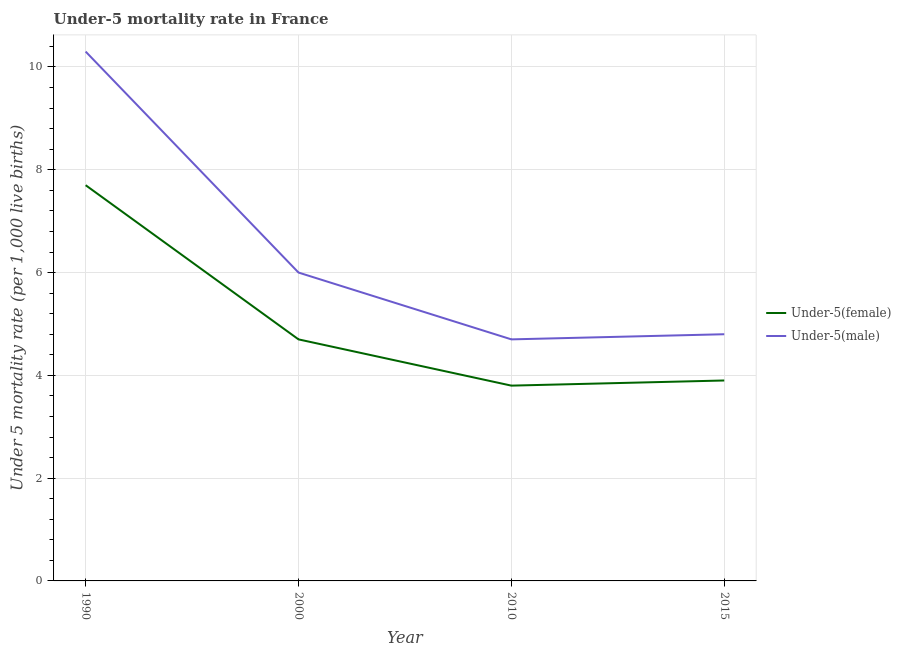How many different coloured lines are there?
Provide a short and direct response. 2. Does the line corresponding to under-5 male mortality rate intersect with the line corresponding to under-5 female mortality rate?
Your answer should be compact. No. In which year was the under-5 male mortality rate maximum?
Your answer should be very brief. 1990. What is the total under-5 female mortality rate in the graph?
Your answer should be very brief. 20.1. What is the difference between the under-5 male mortality rate in 1990 and that in 2000?
Your answer should be very brief. 4.3. What is the difference between the under-5 male mortality rate in 2015 and the under-5 female mortality rate in 1990?
Ensure brevity in your answer.  -2.9. What is the average under-5 male mortality rate per year?
Offer a very short reply. 6.45. In the year 2015, what is the difference between the under-5 female mortality rate and under-5 male mortality rate?
Give a very brief answer. -0.9. In how many years, is the under-5 female mortality rate greater than 8.4?
Offer a terse response. 0. What is the ratio of the under-5 female mortality rate in 2010 to that in 2015?
Provide a short and direct response. 0.97. Is the difference between the under-5 male mortality rate in 1990 and 2000 greater than the difference between the under-5 female mortality rate in 1990 and 2000?
Ensure brevity in your answer.  Yes. What is the difference between the highest and the second highest under-5 male mortality rate?
Provide a succinct answer. 4.3. What is the difference between the highest and the lowest under-5 male mortality rate?
Give a very brief answer. 5.6. Is the sum of the under-5 female mortality rate in 1990 and 2000 greater than the maximum under-5 male mortality rate across all years?
Give a very brief answer. Yes. Does the under-5 female mortality rate monotonically increase over the years?
Provide a succinct answer. No. Is the under-5 male mortality rate strictly greater than the under-5 female mortality rate over the years?
Provide a short and direct response. Yes. How many lines are there?
Ensure brevity in your answer.  2. What is the difference between two consecutive major ticks on the Y-axis?
Ensure brevity in your answer.  2. Are the values on the major ticks of Y-axis written in scientific E-notation?
Your answer should be compact. No. Where does the legend appear in the graph?
Your answer should be very brief. Center right. How many legend labels are there?
Your answer should be very brief. 2. What is the title of the graph?
Provide a succinct answer. Under-5 mortality rate in France. Does "Depositors" appear as one of the legend labels in the graph?
Make the answer very short. No. What is the label or title of the X-axis?
Your answer should be compact. Year. What is the label or title of the Y-axis?
Your answer should be compact. Under 5 mortality rate (per 1,0 live births). What is the Under 5 mortality rate (per 1,000 live births) of Under-5(female) in 1990?
Make the answer very short. 7.7. What is the Under 5 mortality rate (per 1,000 live births) in Under-5(male) in 1990?
Make the answer very short. 10.3. What is the Under 5 mortality rate (per 1,000 live births) in Under-5(female) in 2000?
Your answer should be compact. 4.7. What is the Under 5 mortality rate (per 1,000 live births) in Under-5(male) in 2000?
Offer a very short reply. 6. What is the Under 5 mortality rate (per 1,000 live births) in Under-5(female) in 2010?
Make the answer very short. 3.8. What is the Under 5 mortality rate (per 1,000 live births) of Under-5(male) in 2010?
Your response must be concise. 4.7. What is the Under 5 mortality rate (per 1,000 live births) in Under-5(male) in 2015?
Give a very brief answer. 4.8. Across all years, what is the minimum Under 5 mortality rate (per 1,000 live births) in Under-5(female)?
Keep it short and to the point. 3.8. Across all years, what is the minimum Under 5 mortality rate (per 1,000 live births) in Under-5(male)?
Offer a terse response. 4.7. What is the total Under 5 mortality rate (per 1,000 live births) in Under-5(female) in the graph?
Provide a succinct answer. 20.1. What is the total Under 5 mortality rate (per 1,000 live births) of Under-5(male) in the graph?
Offer a terse response. 25.8. What is the difference between the Under 5 mortality rate (per 1,000 live births) of Under-5(male) in 1990 and that in 2000?
Offer a very short reply. 4.3. What is the difference between the Under 5 mortality rate (per 1,000 live births) of Under-5(female) in 1990 and that in 2010?
Your answer should be very brief. 3.9. What is the difference between the Under 5 mortality rate (per 1,000 live births) of Under-5(female) in 2000 and that in 2015?
Offer a terse response. 0.8. What is the difference between the Under 5 mortality rate (per 1,000 live births) of Under-5(male) in 2010 and that in 2015?
Make the answer very short. -0.1. What is the average Under 5 mortality rate (per 1,000 live births) of Under-5(female) per year?
Your answer should be compact. 5.03. What is the average Under 5 mortality rate (per 1,000 live births) in Under-5(male) per year?
Provide a succinct answer. 6.45. In the year 1990, what is the difference between the Under 5 mortality rate (per 1,000 live births) in Under-5(female) and Under 5 mortality rate (per 1,000 live births) in Under-5(male)?
Offer a terse response. -2.6. In the year 2000, what is the difference between the Under 5 mortality rate (per 1,000 live births) of Under-5(female) and Under 5 mortality rate (per 1,000 live births) of Under-5(male)?
Your answer should be compact. -1.3. In the year 2015, what is the difference between the Under 5 mortality rate (per 1,000 live births) in Under-5(female) and Under 5 mortality rate (per 1,000 live births) in Under-5(male)?
Ensure brevity in your answer.  -0.9. What is the ratio of the Under 5 mortality rate (per 1,000 live births) of Under-5(female) in 1990 to that in 2000?
Provide a short and direct response. 1.64. What is the ratio of the Under 5 mortality rate (per 1,000 live births) in Under-5(male) in 1990 to that in 2000?
Provide a short and direct response. 1.72. What is the ratio of the Under 5 mortality rate (per 1,000 live births) in Under-5(female) in 1990 to that in 2010?
Your answer should be compact. 2.03. What is the ratio of the Under 5 mortality rate (per 1,000 live births) in Under-5(male) in 1990 to that in 2010?
Offer a terse response. 2.19. What is the ratio of the Under 5 mortality rate (per 1,000 live births) of Under-5(female) in 1990 to that in 2015?
Make the answer very short. 1.97. What is the ratio of the Under 5 mortality rate (per 1,000 live births) in Under-5(male) in 1990 to that in 2015?
Provide a succinct answer. 2.15. What is the ratio of the Under 5 mortality rate (per 1,000 live births) of Under-5(female) in 2000 to that in 2010?
Make the answer very short. 1.24. What is the ratio of the Under 5 mortality rate (per 1,000 live births) in Under-5(male) in 2000 to that in 2010?
Give a very brief answer. 1.28. What is the ratio of the Under 5 mortality rate (per 1,000 live births) in Under-5(female) in 2000 to that in 2015?
Provide a succinct answer. 1.21. What is the ratio of the Under 5 mortality rate (per 1,000 live births) in Under-5(male) in 2000 to that in 2015?
Offer a terse response. 1.25. What is the ratio of the Under 5 mortality rate (per 1,000 live births) of Under-5(female) in 2010 to that in 2015?
Ensure brevity in your answer.  0.97. What is the ratio of the Under 5 mortality rate (per 1,000 live births) in Under-5(male) in 2010 to that in 2015?
Provide a short and direct response. 0.98. What is the difference between the highest and the lowest Under 5 mortality rate (per 1,000 live births) of Under-5(female)?
Your answer should be very brief. 3.9. 